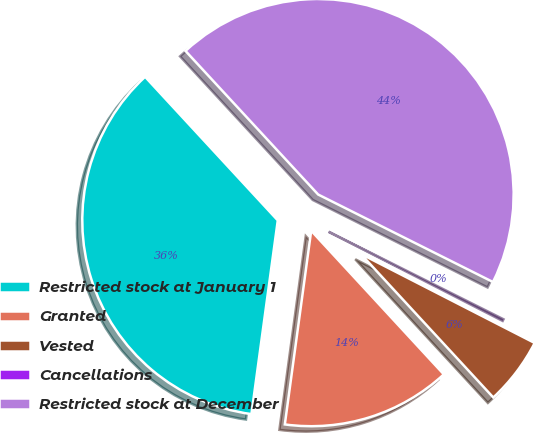Convert chart. <chart><loc_0><loc_0><loc_500><loc_500><pie_chart><fcel>Restricted stock at January 1<fcel>Granted<fcel>Vested<fcel>Cancellations<fcel>Restricted stock at December<nl><fcel>35.98%<fcel>14.02%<fcel>5.6%<fcel>0.15%<fcel>44.26%<nl></chart> 